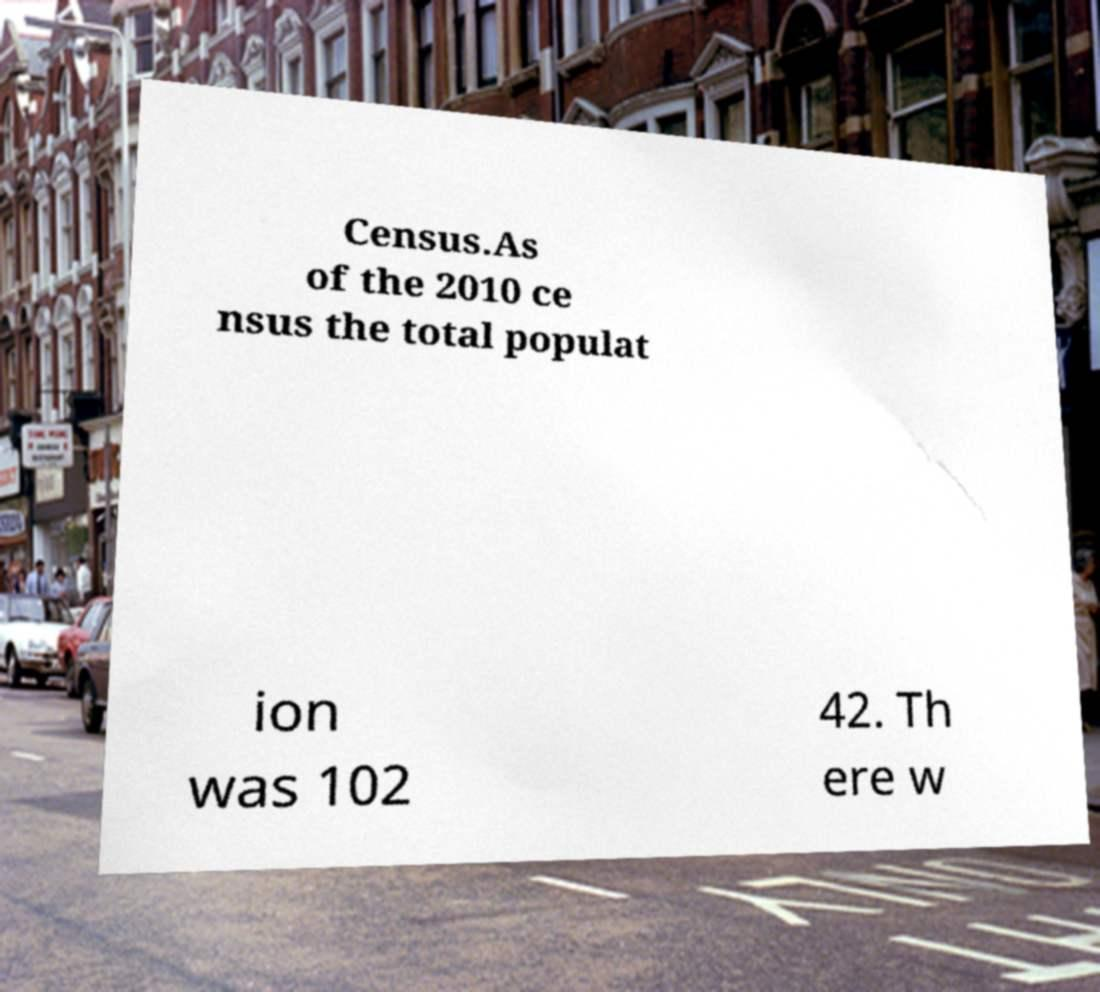There's text embedded in this image that I need extracted. Can you transcribe it verbatim? Census.As of the 2010 ce nsus the total populat ion was 102 42. Th ere w 